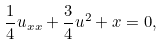Convert formula to latex. <formula><loc_0><loc_0><loc_500><loc_500>\frac { 1 } { 4 } u _ { x x } + \frac { 3 } { 4 } u ^ { 2 } + x = 0 ,</formula> 